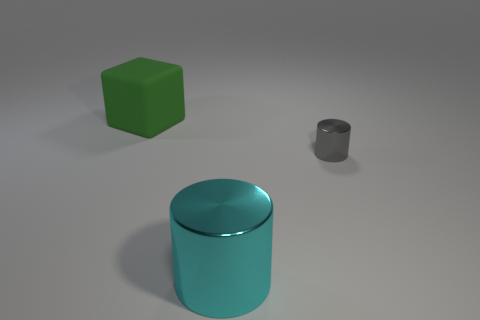Can you describe the shapes and their sizes relative to each other? Certainly! In the image, you have three distinct shapes. The largest is a cyan cylinder, which appears to be in the foreground. To its left is a medium-sized green cube, and there's also a smaller grey cylinder further to the right. 